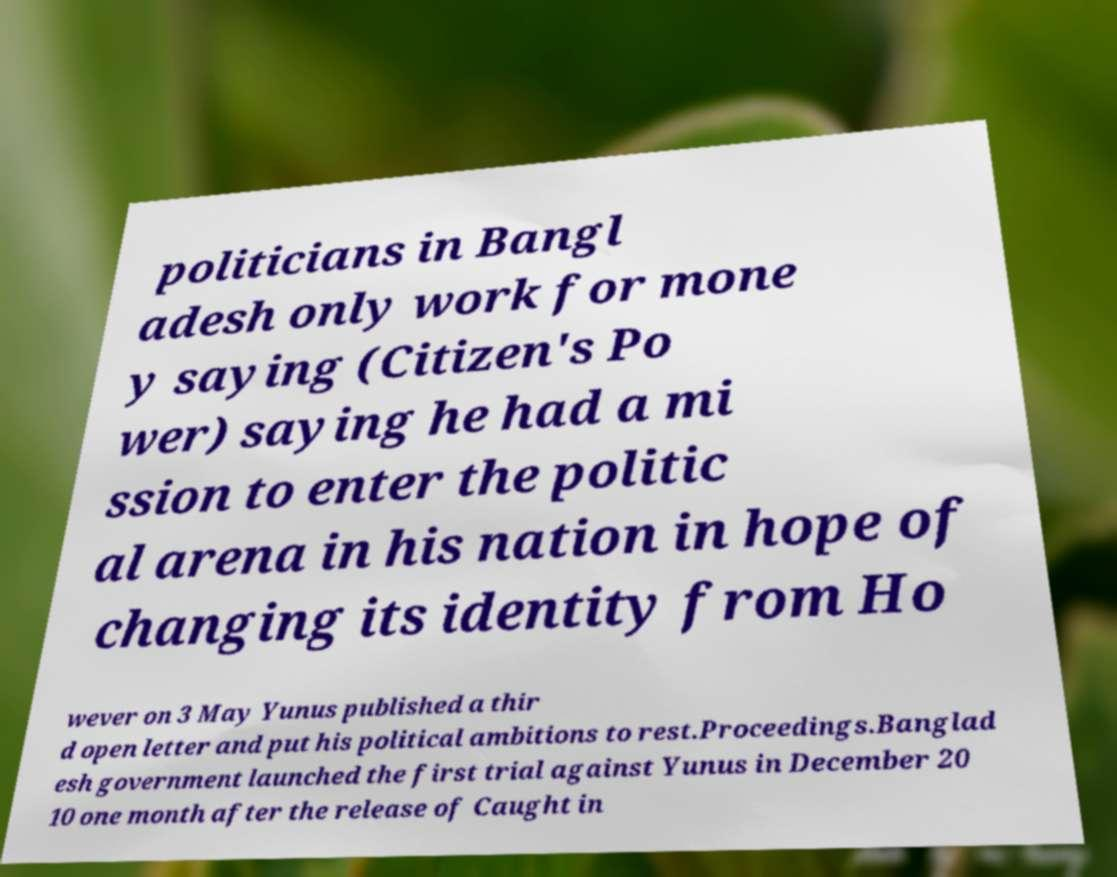I need the written content from this picture converted into text. Can you do that? politicians in Bangl adesh only work for mone y saying (Citizen's Po wer) saying he had a mi ssion to enter the politic al arena in his nation in hope of changing its identity from Ho wever on 3 May Yunus published a thir d open letter and put his political ambitions to rest.Proceedings.Banglad esh government launched the first trial against Yunus in December 20 10 one month after the release of Caught in 